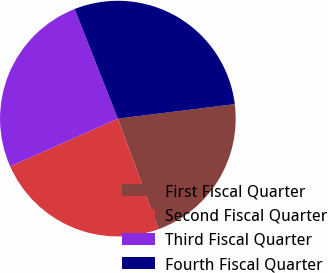Convert chart to OTSL. <chart><loc_0><loc_0><loc_500><loc_500><pie_chart><fcel>First Fiscal Quarter<fcel>Second Fiscal Quarter<fcel>Third Fiscal Quarter<fcel>Fourth Fiscal Quarter<nl><fcel>21.34%<fcel>23.97%<fcel>25.67%<fcel>29.02%<nl></chart> 